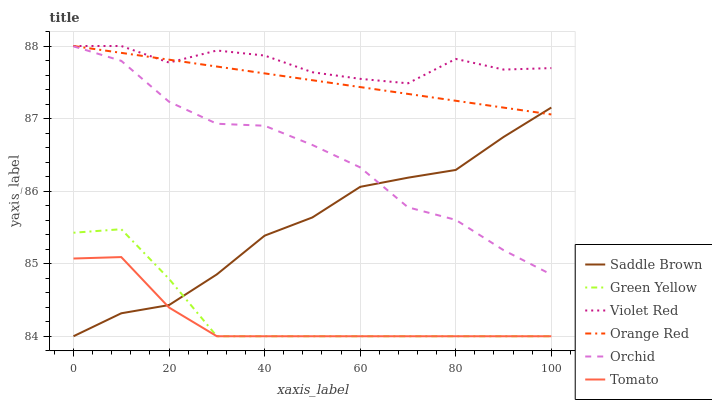Does Tomato have the minimum area under the curve?
Answer yes or no. Yes. Does Violet Red have the maximum area under the curve?
Answer yes or no. Yes. Does Orange Red have the minimum area under the curve?
Answer yes or no. No. Does Orange Red have the maximum area under the curve?
Answer yes or no. No. Is Orange Red the smoothest?
Answer yes or no. Yes. Is Violet Red the roughest?
Answer yes or no. Yes. Is Violet Red the smoothest?
Answer yes or no. No. Is Orange Red the roughest?
Answer yes or no. No. Does Tomato have the lowest value?
Answer yes or no. Yes. Does Orange Red have the lowest value?
Answer yes or no. No. Does Orange Red have the highest value?
Answer yes or no. Yes. Does Green Yellow have the highest value?
Answer yes or no. No. Is Green Yellow less than Orchid?
Answer yes or no. Yes. Is Violet Red greater than Tomato?
Answer yes or no. Yes. Does Orange Red intersect Saddle Brown?
Answer yes or no. Yes. Is Orange Red less than Saddle Brown?
Answer yes or no. No. Is Orange Red greater than Saddle Brown?
Answer yes or no. No. Does Green Yellow intersect Orchid?
Answer yes or no. No. 